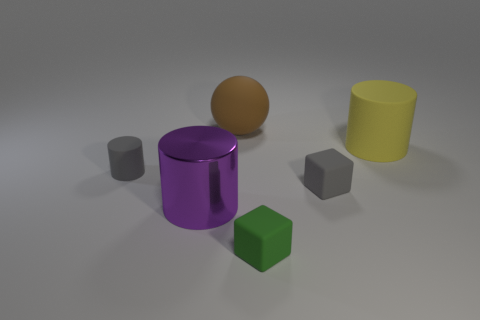There is a tiny cylinder; is its color the same as the rubber block that is behind the big purple metallic object? Yes, the tiny cylinder shares the same color as the rubber block positioned behind the large purple metallic object, which is a shade of gray. 